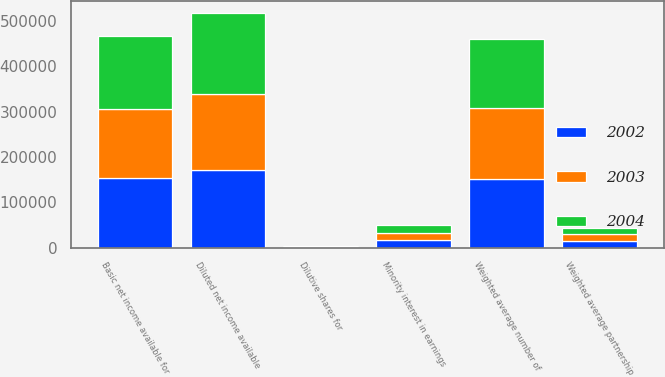<chart> <loc_0><loc_0><loc_500><loc_500><stacked_bar_chart><ecel><fcel>Basic net income available for<fcel>Minority interest in earnings<fcel>Diluted net income available<fcel>Weighted average number of<fcel>Weighted average partnership<fcel>Dilutive shares for<nl><fcel>2003<fcel>151279<fcel>14966<fcel>166245<fcel>157062<fcel>13902<fcel>904<nl><fcel>2004<fcel>161911<fcel>17546<fcel>179457<fcel>151141<fcel>14685<fcel>861<nl><fcel>2002<fcel>153969<fcel>17726<fcel>171695<fcel>150839<fcel>15442<fcel>1416<nl></chart> 